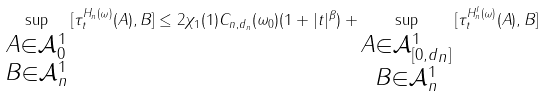<formula> <loc_0><loc_0><loc_500><loc_500>\sup _ { \substack { A \in \mathcal { A } _ { 0 } ^ { 1 } \\ B \in \mathcal { A } _ { n } ^ { 1 } } } \| [ \tau _ { t } ^ { H _ { n } ( \omega ) } ( A ) , B ] \| \leq 2 \chi _ { 1 } ( 1 ) C _ { n , d _ { n } } ( \omega _ { 0 } ) ( 1 + | t | ^ { \beta } ) + \sup _ { \substack { A \in \mathcal { A } _ { [ 0 , d _ { n } ] } ^ { 1 } \\ B \in \mathcal { A } _ { n } ^ { 1 } } } \| [ \tau _ { t } ^ { H _ { n } ^ { I } ( \omega ) } ( A ) , B ] \|</formula> 